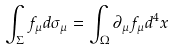<formula> <loc_0><loc_0><loc_500><loc_500>\int _ { \Sigma } f _ { \mu } d \sigma _ { \mu } = \int _ { \Omega } \partial _ { \mu } f _ { \mu } d ^ { 4 } x</formula> 